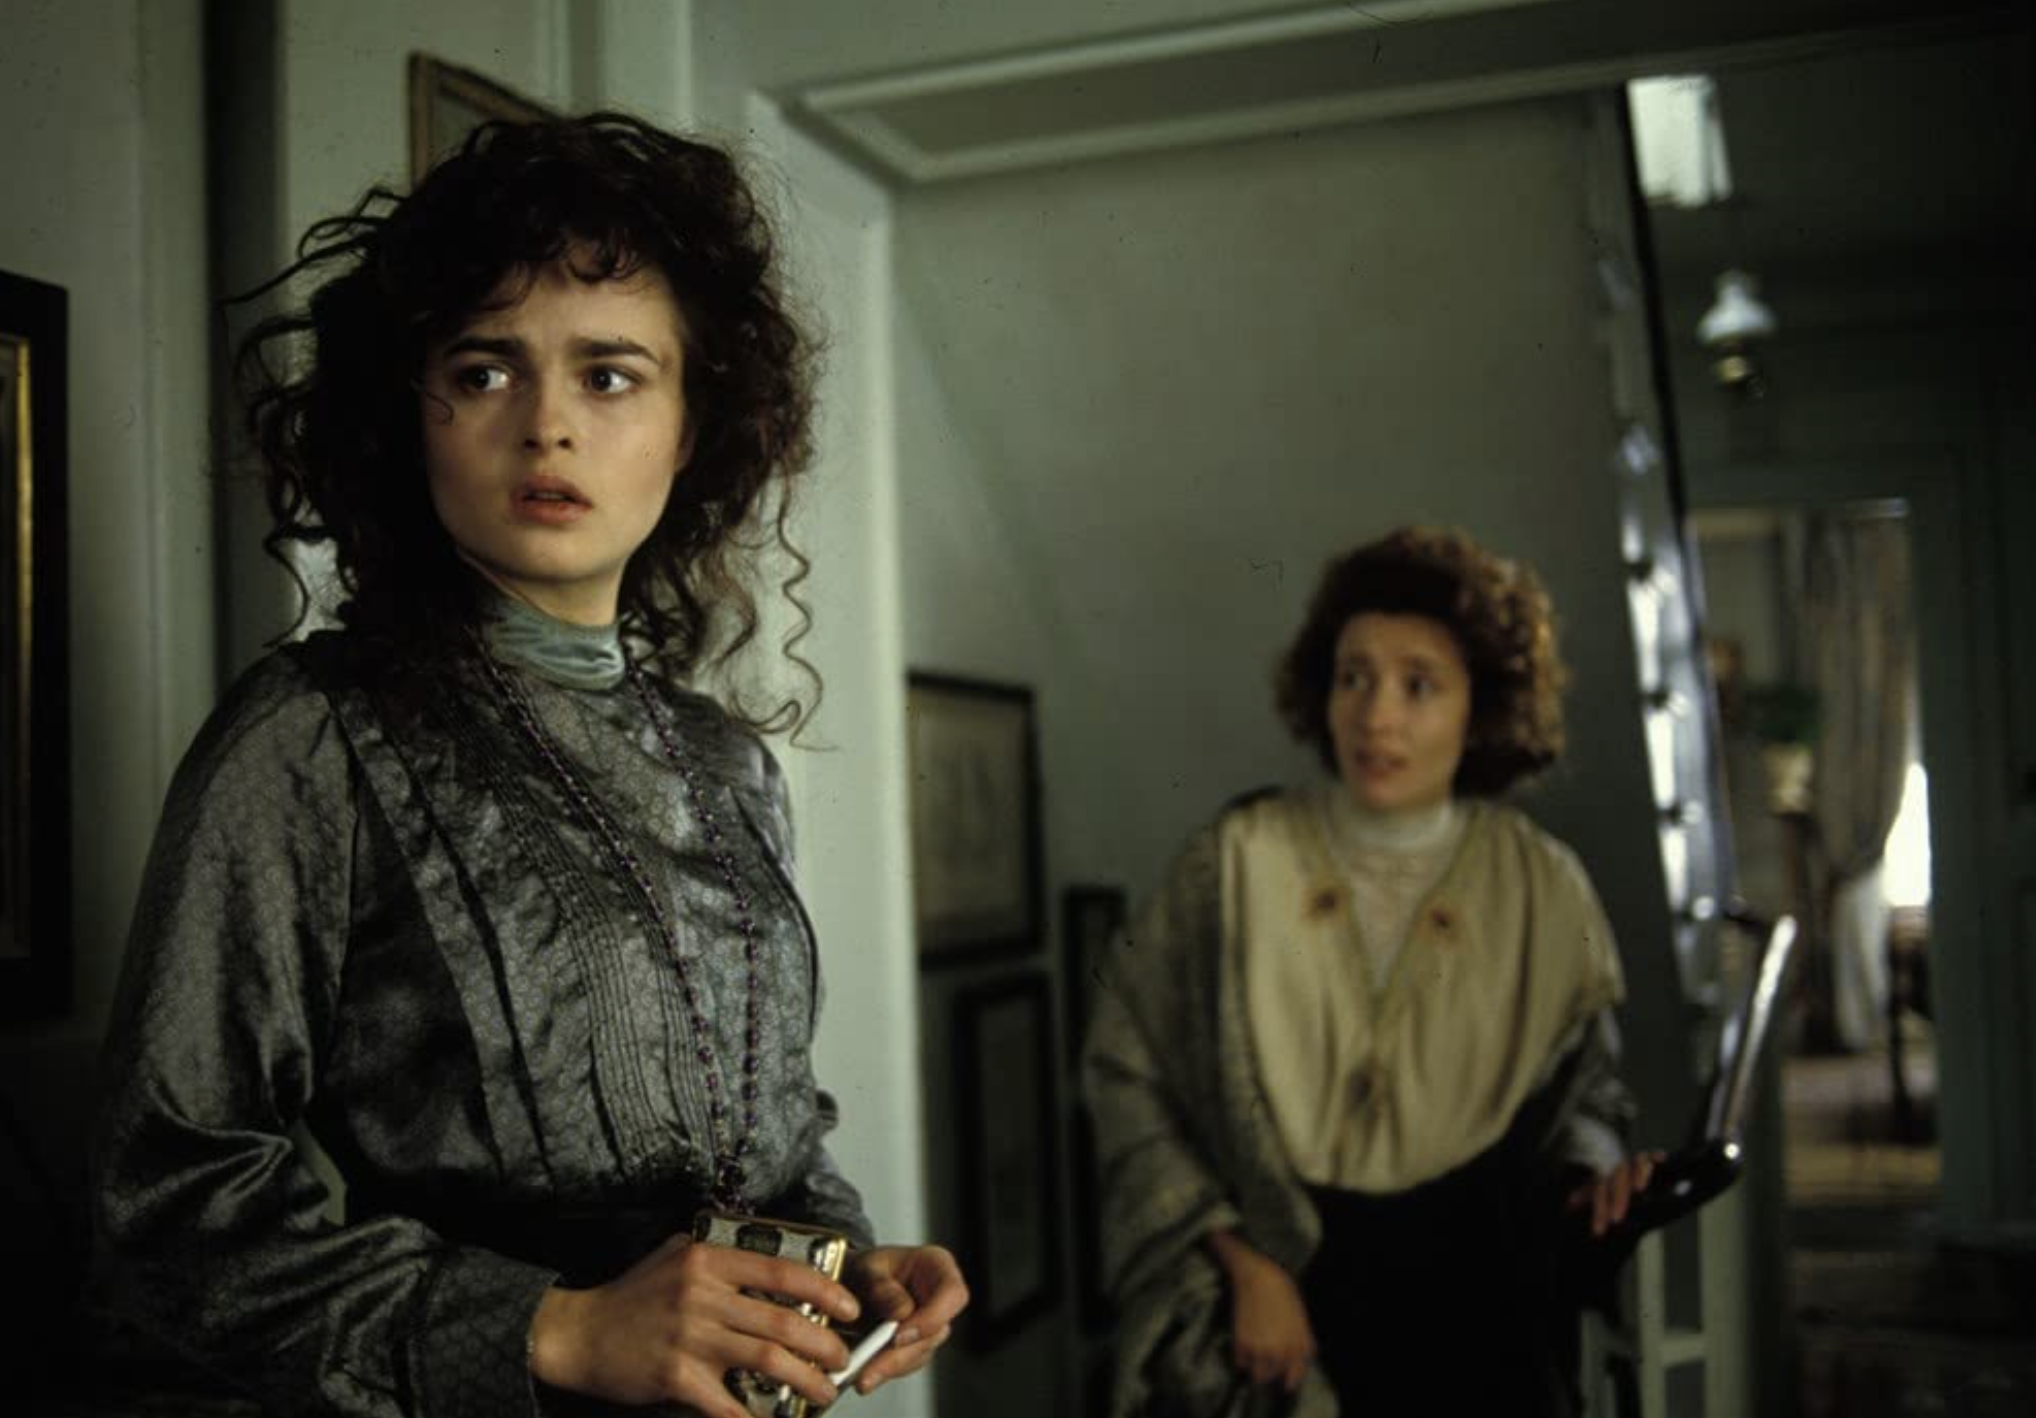What historical era do the fashion and decor suggest? The attire and room decor hint at a setting that could align with the late Victorian or Edwardian era, characterized by high collars, intricate clothing patterns, and subdued color palettes in interior design. The aesthetic details evoke a sense of history and suggest a narrative rooted in a time of significant cultural norms and values from the past. 